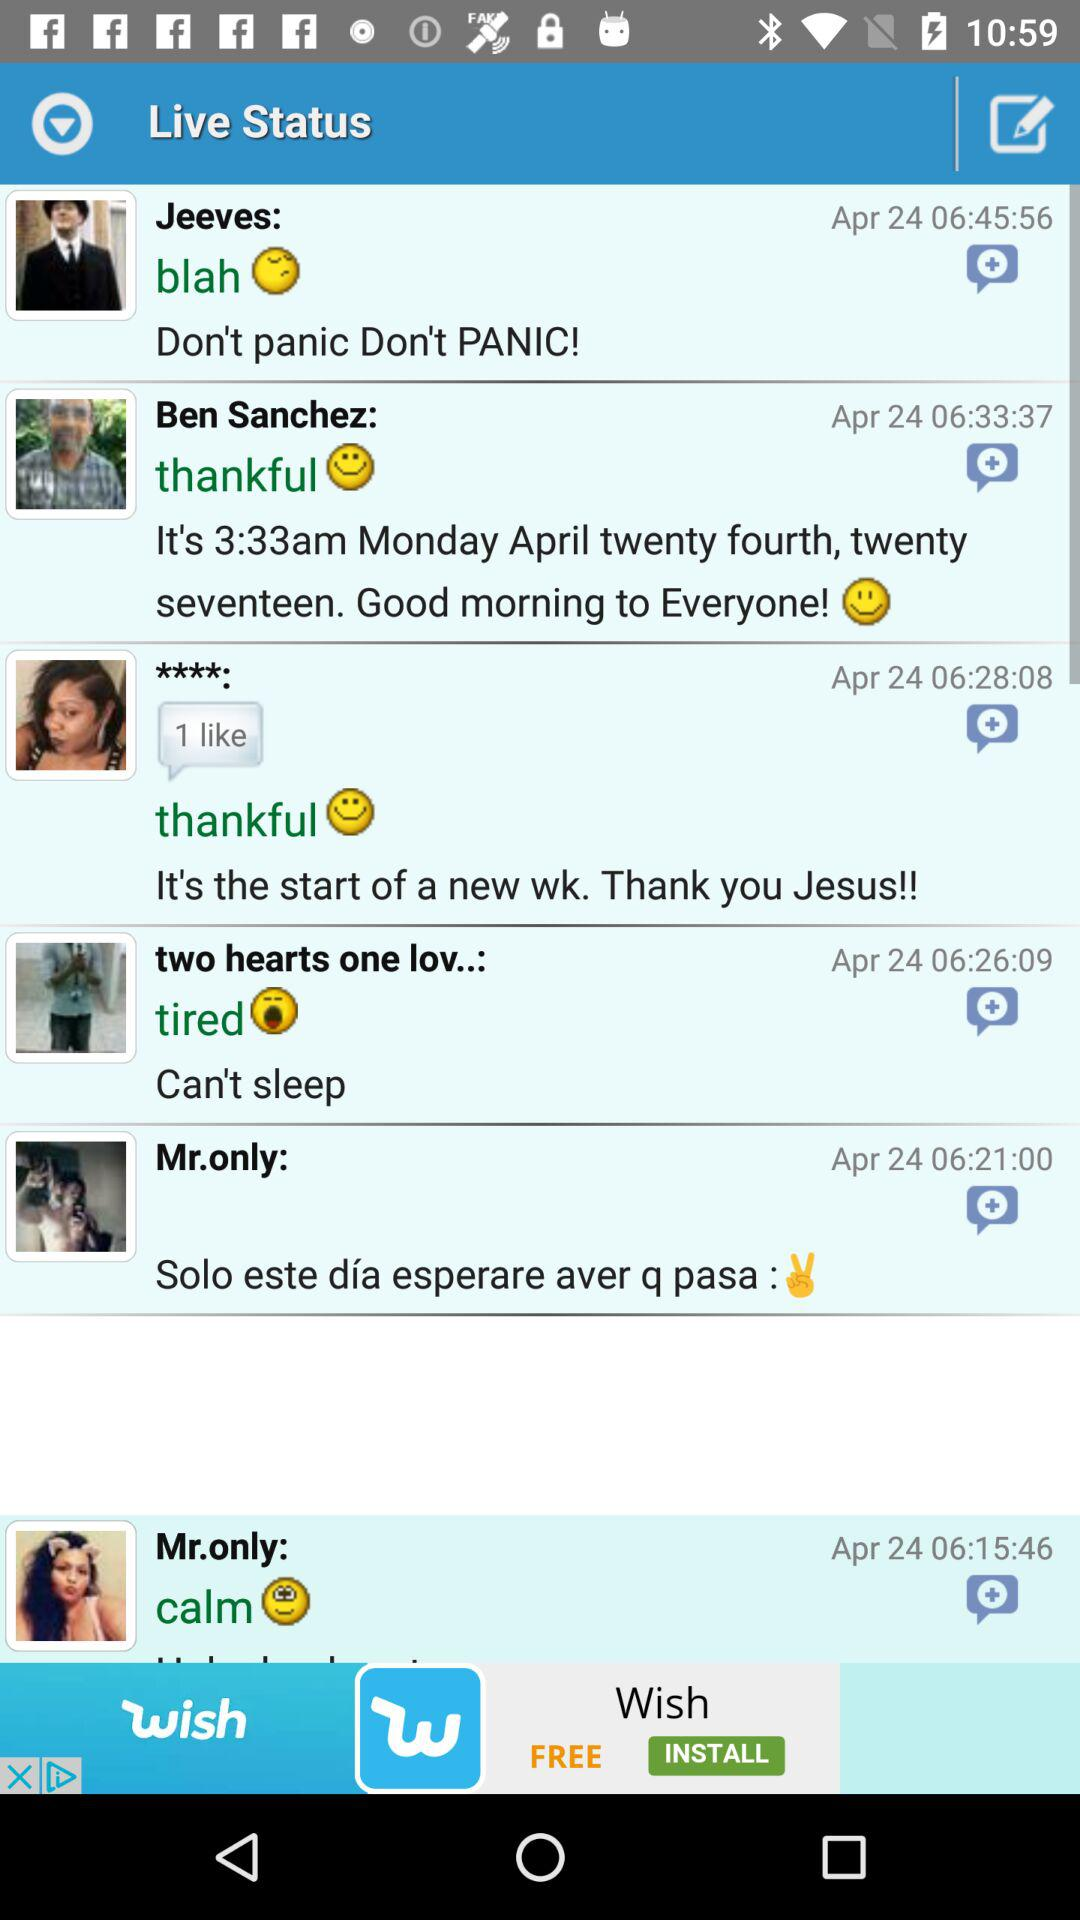What is the time for the status of Ben Sanchez? The time for the status of Ben Sanchez is 06:33:37. 